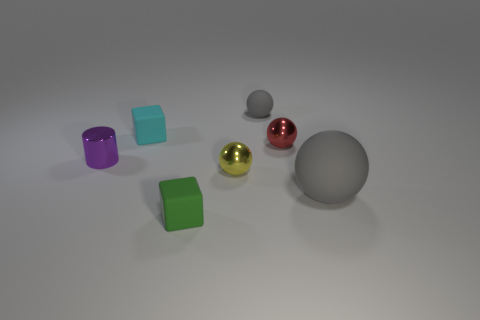There is a cube behind the small cylinder; is its size the same as the sphere that is in front of the tiny yellow metallic sphere?
Your response must be concise. No. What material is the gray ball that is the same size as the green rubber object?
Give a very brief answer. Rubber. What is the tiny thing that is both behind the red metallic ball and on the right side of the small cyan rubber object made of?
Provide a succinct answer. Rubber. Are any tiny green cubes visible?
Give a very brief answer. Yes. Is the color of the large rubber object the same as the matte sphere behind the tiny shiny cylinder?
Make the answer very short. Yes. Are there any other things that are the same shape as the small purple thing?
Your response must be concise. No. There is a gray thing that is right of the thing that is behind the cube that is behind the green cube; what is its shape?
Provide a short and direct response. Sphere. The large rubber object has what shape?
Your answer should be very brief. Sphere. There is a rubber object on the right side of the small rubber sphere; what color is it?
Your answer should be compact. Gray. There is a metal sphere that is behind the purple thing; is its size the same as the small yellow ball?
Your answer should be very brief. Yes. 